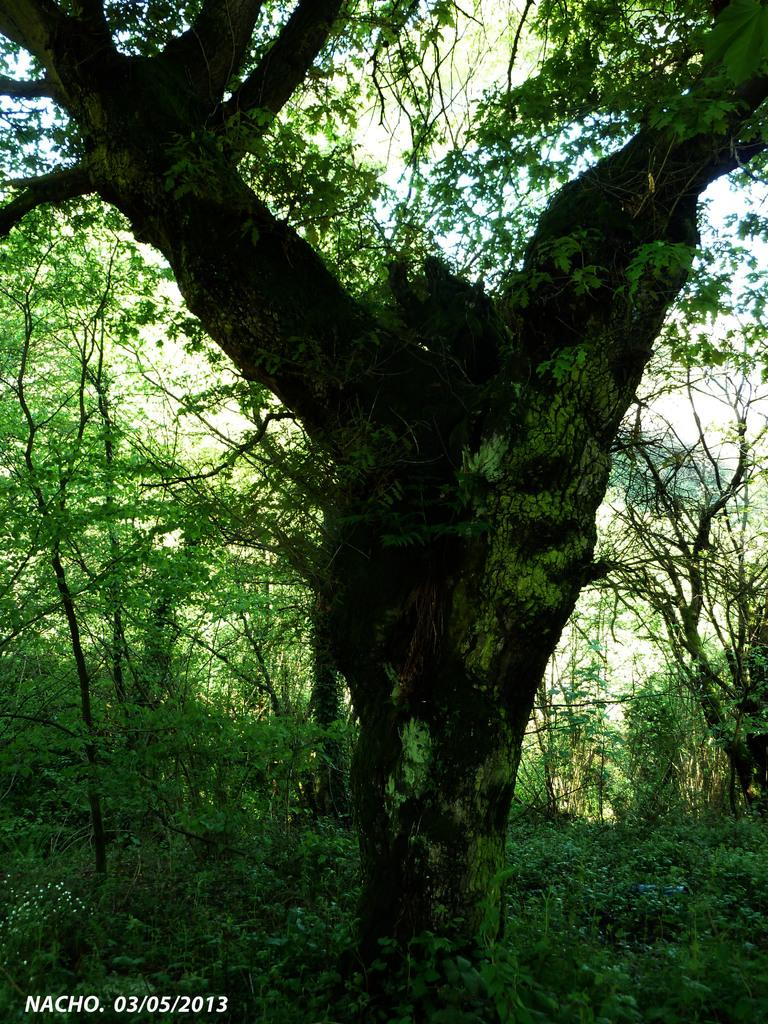What type of vegetation is present in the image? There is a tree, grass, and plants in the image. What can be seen in the background of the image? The sky is visible at the top of the image. What type of lunch is being served in the image? There is no lunch or any food visible in the image; it only features a tree, grass, plants, and the sky. How many planes can be seen flying in the image? There are no planes present in the image. 